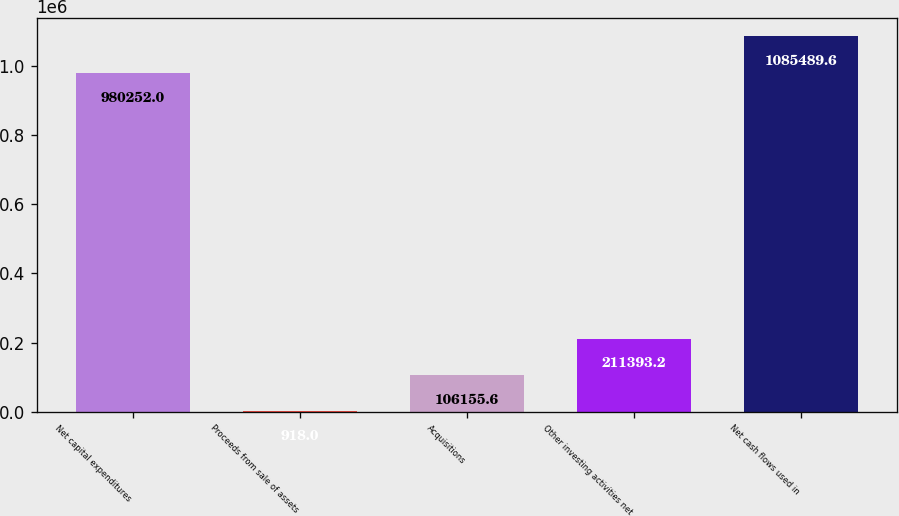Convert chart to OTSL. <chart><loc_0><loc_0><loc_500><loc_500><bar_chart><fcel>Net capital expenditures<fcel>Proceeds from sale of assets<fcel>Acquisitions<fcel>Other investing activities net<fcel>Net cash flows used in<nl><fcel>980252<fcel>918<fcel>106156<fcel>211393<fcel>1.08549e+06<nl></chart> 